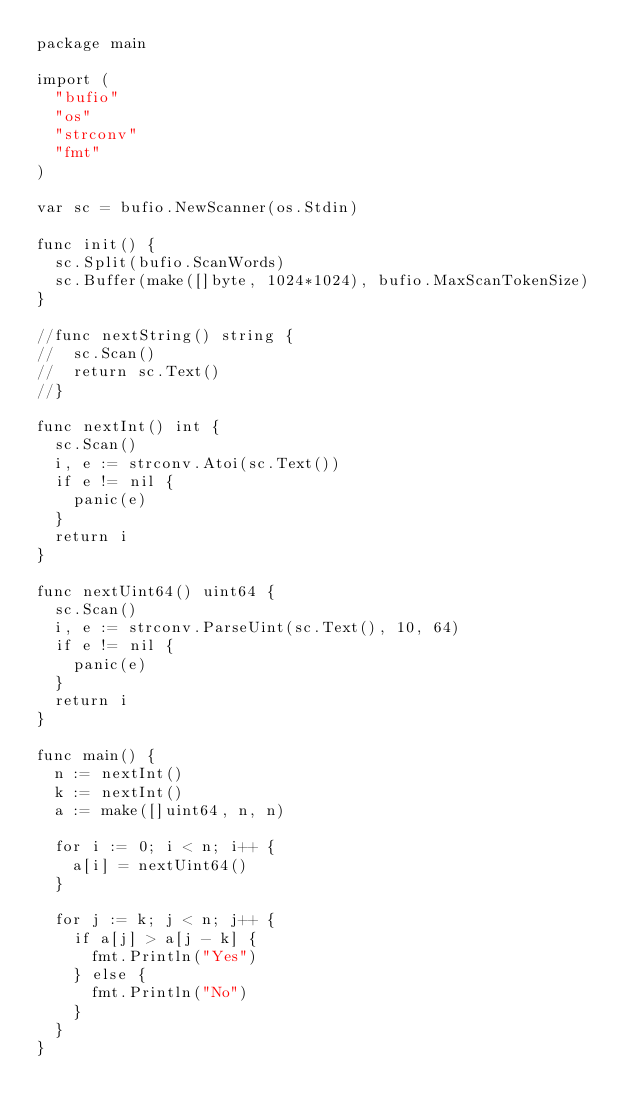<code> <loc_0><loc_0><loc_500><loc_500><_Go_>package main

import (
	"bufio"
	"os"
	"strconv"
	"fmt"
)

var sc = bufio.NewScanner(os.Stdin)

func init() {
	sc.Split(bufio.ScanWords)
	sc.Buffer(make([]byte, 1024*1024), bufio.MaxScanTokenSize)
}

//func nextString() string {
//	sc.Scan()
//	return sc.Text()
//}

func nextInt() int {
	sc.Scan()
	i, e := strconv.Atoi(sc.Text())
	if e != nil {
		panic(e)
	}
	return i
}

func nextUint64() uint64 {
	sc.Scan()
	i, e := strconv.ParseUint(sc.Text(), 10, 64)
	if e != nil {
		panic(e)
	}
	return i
}

func main() {
	n := nextInt()
	k := nextInt()
	a := make([]uint64, n, n)

	for i := 0; i < n; i++ {
		a[i] = nextUint64()
	}

	for j := k; j < n; j++ {
		if a[j] > a[j - k] {
			fmt.Println("Yes")
		} else {
			fmt.Println("No")
		}
	}
}</code> 